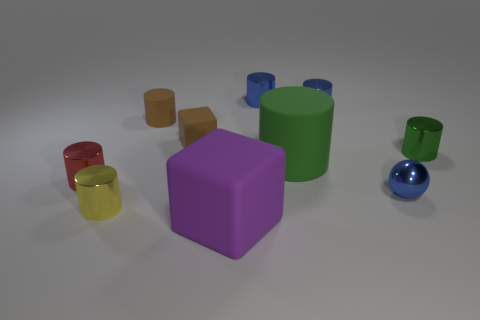Subtract 3 cylinders. How many cylinders are left? 4 Subtract all brown cylinders. How many cylinders are left? 6 Subtract all brown matte cylinders. How many cylinders are left? 6 Subtract all purple cubes. Subtract all yellow cylinders. How many cubes are left? 1 Subtract all blocks. How many objects are left? 8 Subtract 0 brown spheres. How many objects are left? 10 Subtract all small matte blocks. Subtract all small blue metal spheres. How many objects are left? 8 Add 3 green cylinders. How many green cylinders are left? 5 Add 9 tiny gray shiny things. How many tiny gray shiny things exist? 9 